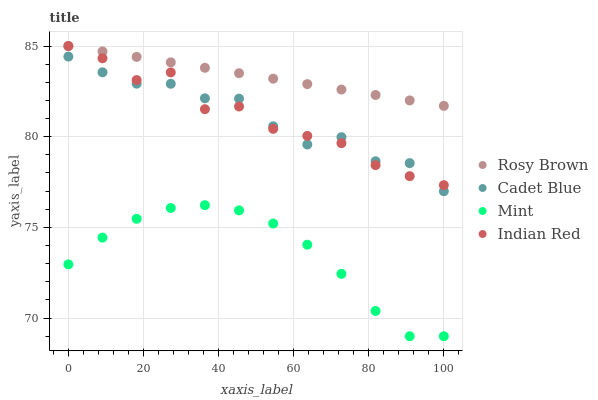Does Mint have the minimum area under the curve?
Answer yes or no. Yes. Does Rosy Brown have the maximum area under the curve?
Answer yes or no. Yes. Does Rosy Brown have the minimum area under the curve?
Answer yes or no. No. Does Mint have the maximum area under the curve?
Answer yes or no. No. Is Rosy Brown the smoothest?
Answer yes or no. Yes. Is Indian Red the roughest?
Answer yes or no. Yes. Is Mint the smoothest?
Answer yes or no. No. Is Mint the roughest?
Answer yes or no. No. Does Mint have the lowest value?
Answer yes or no. Yes. Does Rosy Brown have the lowest value?
Answer yes or no. No. Does Indian Red have the highest value?
Answer yes or no. Yes. Does Mint have the highest value?
Answer yes or no. No. Is Mint less than Cadet Blue?
Answer yes or no. Yes. Is Rosy Brown greater than Mint?
Answer yes or no. Yes. Does Rosy Brown intersect Indian Red?
Answer yes or no. Yes. Is Rosy Brown less than Indian Red?
Answer yes or no. No. Is Rosy Brown greater than Indian Red?
Answer yes or no. No. Does Mint intersect Cadet Blue?
Answer yes or no. No. 